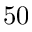Convert formula to latex. <formula><loc_0><loc_0><loc_500><loc_500>5 0</formula> 